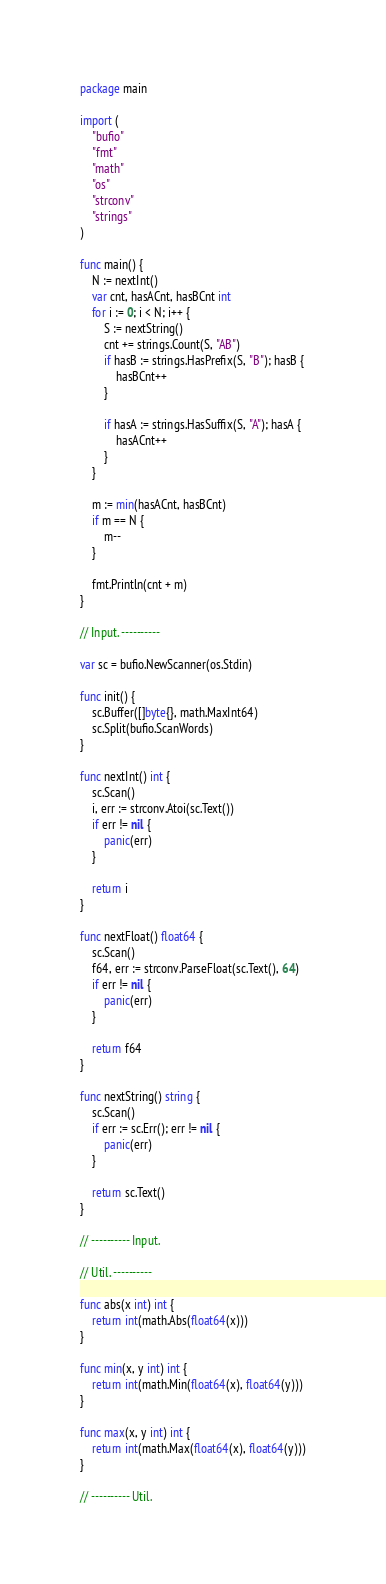<code> <loc_0><loc_0><loc_500><loc_500><_Go_>package main

import (
	"bufio"
	"fmt"
	"math"
	"os"
	"strconv"
	"strings"
)

func main() {
	N := nextInt()
	var cnt, hasACnt, hasBCnt int
	for i := 0; i < N; i++ {
		S := nextString()
		cnt += strings.Count(S, "AB")
		if hasB := strings.HasPrefix(S, "B"); hasB {
			hasBCnt++
		}

		if hasA := strings.HasSuffix(S, "A"); hasA {
			hasACnt++
		}
	}

	m := min(hasACnt, hasBCnt)
	if m == N {
		m--
	}

	fmt.Println(cnt + m)
}

// Input. ----------

var sc = bufio.NewScanner(os.Stdin)

func init() {
	sc.Buffer([]byte{}, math.MaxInt64)
	sc.Split(bufio.ScanWords)
}

func nextInt() int {
	sc.Scan()
	i, err := strconv.Atoi(sc.Text())
	if err != nil {
		panic(err)
	}

	return i
}

func nextFloat() float64 {
	sc.Scan()
	f64, err := strconv.ParseFloat(sc.Text(), 64)
	if err != nil {
		panic(err)
	}

	return f64
}

func nextString() string {
	sc.Scan()
	if err := sc.Err(); err != nil {
		panic(err)
	}

	return sc.Text()
}

// ---------- Input.

// Util. ----------

func abs(x int) int {
	return int(math.Abs(float64(x)))
}

func min(x, y int) int {
	return int(math.Min(float64(x), float64(y)))
}

func max(x, y int) int {
	return int(math.Max(float64(x), float64(y)))
}

// ---------- Util.
</code> 